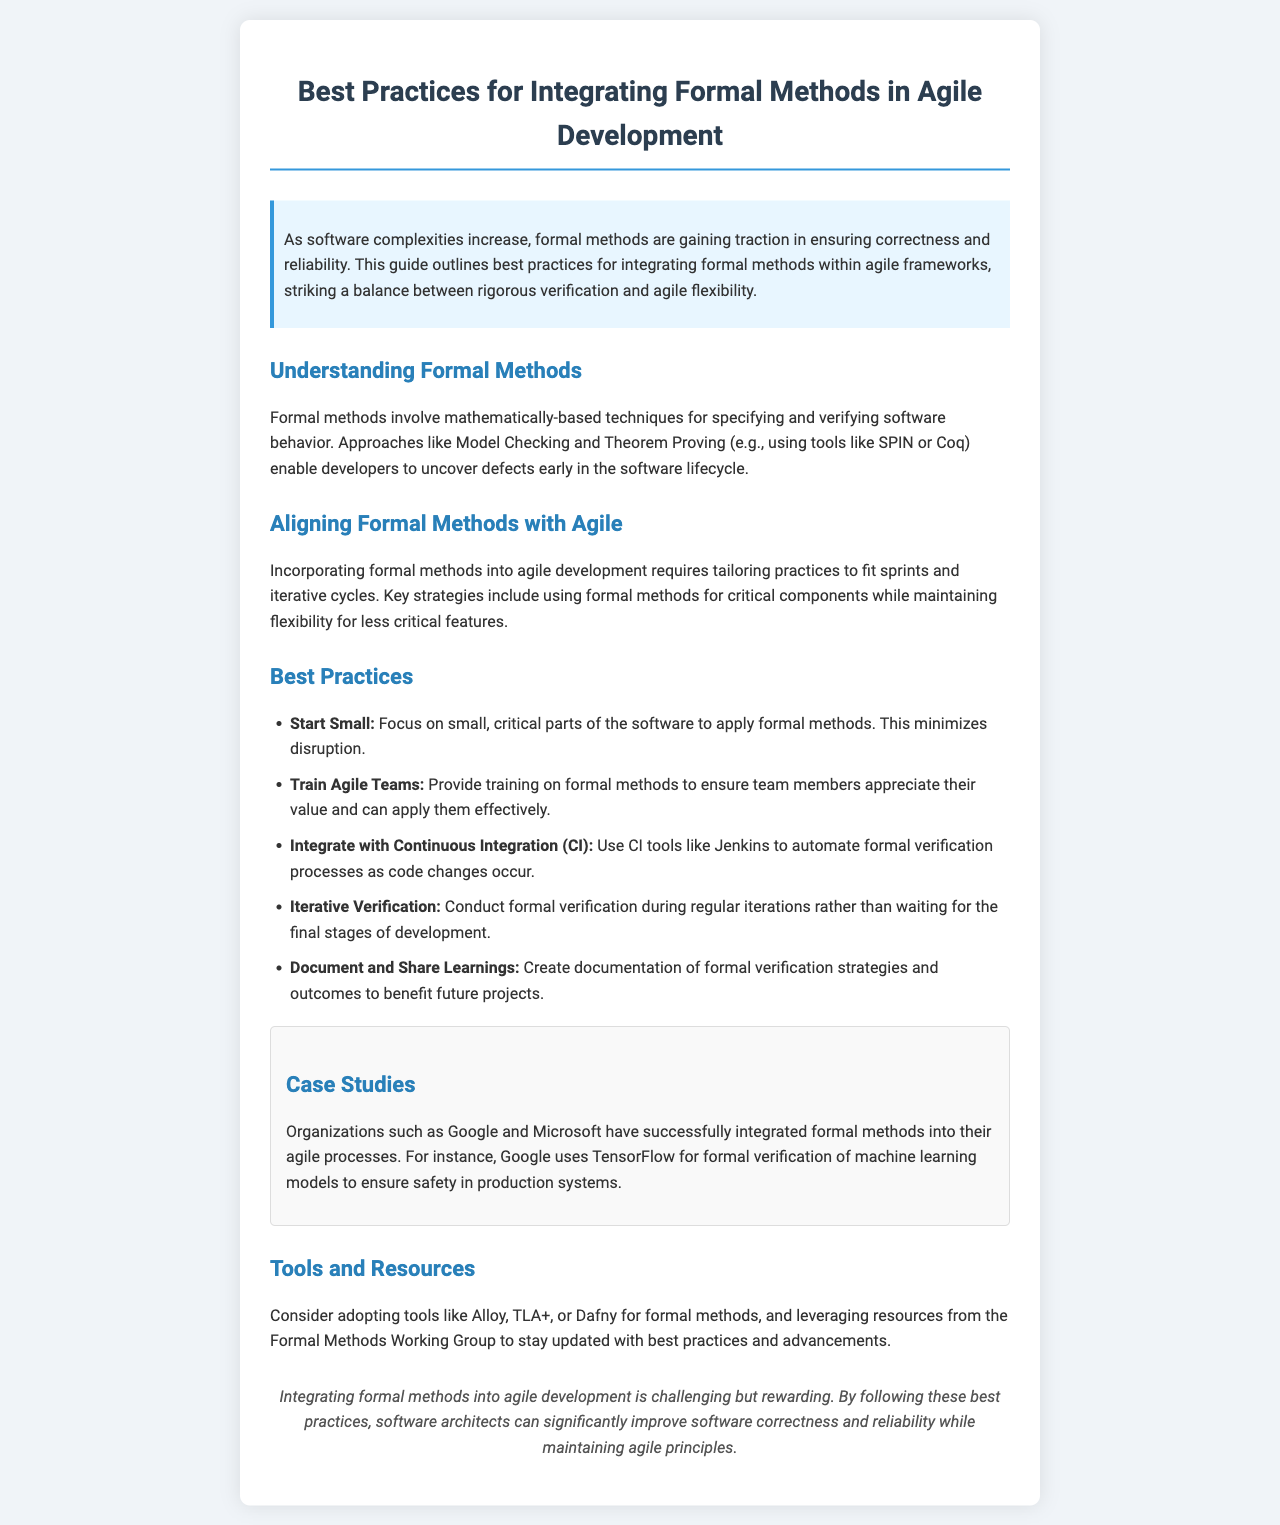what are formal methods? Formal methods involve mathematically-based techniques for specifying and verifying software behavior.
Answer: mathematically-based techniques what is one tool mentioned for formal verification? The document lists tools for formal methods, highlighting one as an example.
Answer: Alloy what is a key strategy for integrating formal methods with agile? This strategy involves adjusting practices to fit agile cycles and involves a specific focus.
Answer: use formal methods for critical components how many best practices are listed in the document? The document provides a list of best practices to follow when integrating formal methods.
Answer: five which organizations are cited in the case studies? The case studies refer to companies that have successfully integrated formal methods.
Answer: Google and Microsoft what is a recommendation for training teams? The document provides a specific piece of advice regarding team training on formal methods.
Answer: Provide training on formal methods what is the main goal of integrating formal methods into agile development? The document discusses the overarching aim of using formal methods in the agile framework.
Answer: improve software correctness and reliability what is the style of the document? The document follows a specific format that influences the way information is presented.
Answer: newsletter what is the purpose of documentation according to the best practices? The document recommends a specific use for documentation related to formal verification.
Answer: benefit future projects 